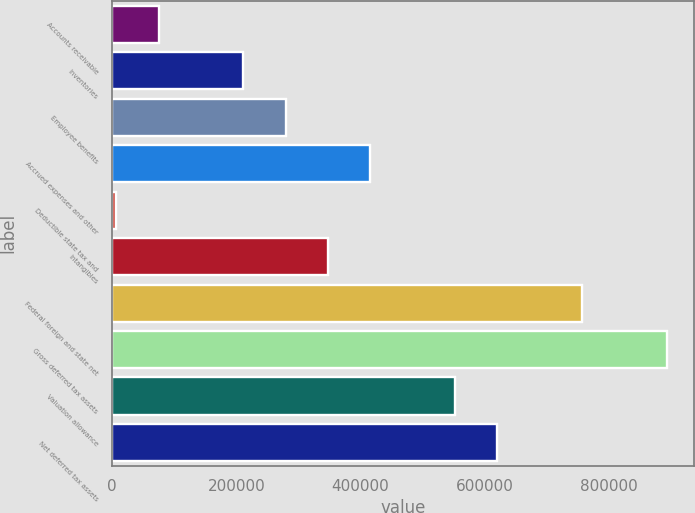Convert chart to OTSL. <chart><loc_0><loc_0><loc_500><loc_500><bar_chart><fcel>Accounts receivable<fcel>Inventories<fcel>Employee benefits<fcel>Accrued expenses and other<fcel>Deductible state tax and<fcel>Intangibles<fcel>Federal foreign and state net<fcel>Gross deferred tax assets<fcel>Valuation allowance<fcel>Net deferred tax assets<nl><fcel>75197.7<fcel>211459<fcel>279590<fcel>415851<fcel>7067<fcel>347720<fcel>756505<fcel>892766<fcel>552113<fcel>620243<nl></chart> 